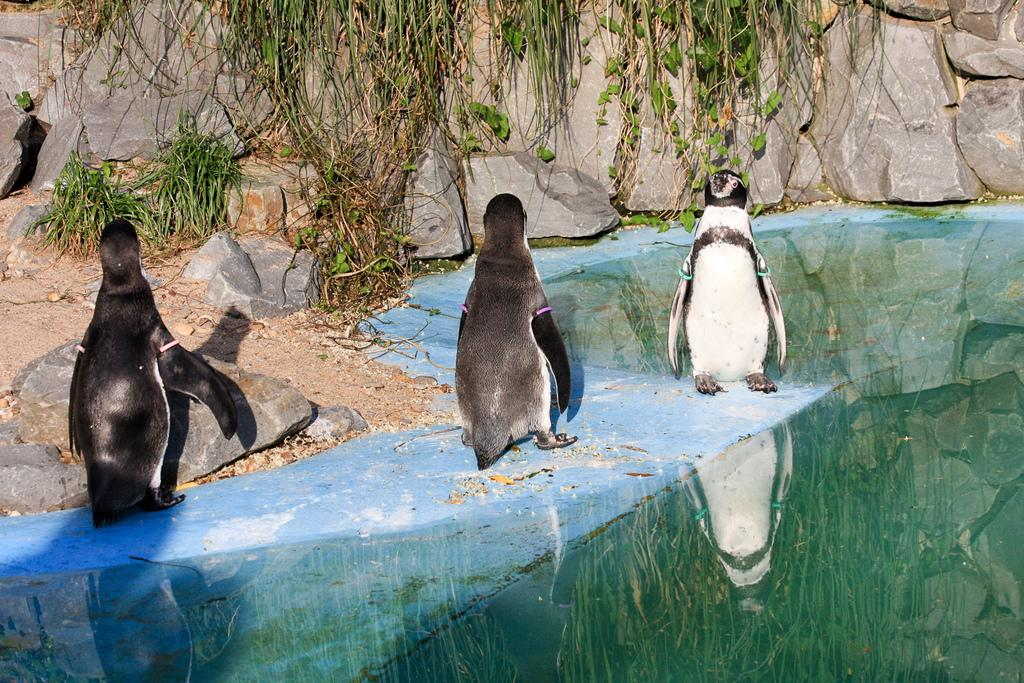What type of animals are in the image? There are penguins in the image. What is the penguins' position in relation to the ground? The penguins are standing on the ground. What can be seen besides the penguins in the image? There is water visible in the image. What is visible in the background of the image? There are rocks and trees in the background of the image. What type of calendar is hanging on the tree in the image? There is no calendar present in the image; it features penguins, water, rocks, and trees. What vegetable can be seen growing near the penguins in the image? There are no vegetables visible in the image; it only shows penguins, water, rocks, and trees. 